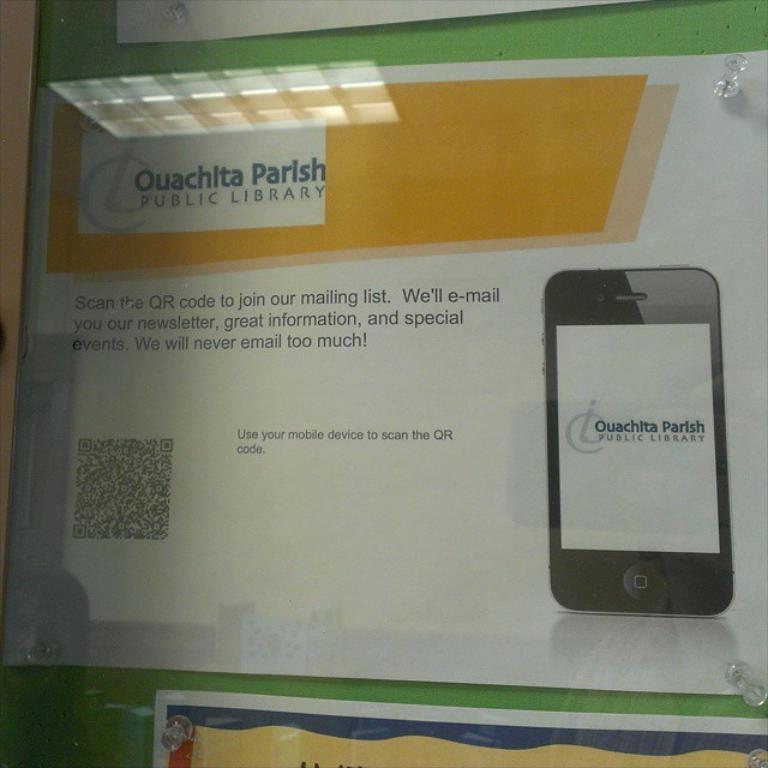<image>
Provide a brief description of the given image. A flyer that reads Quachita Parish Public Library. 